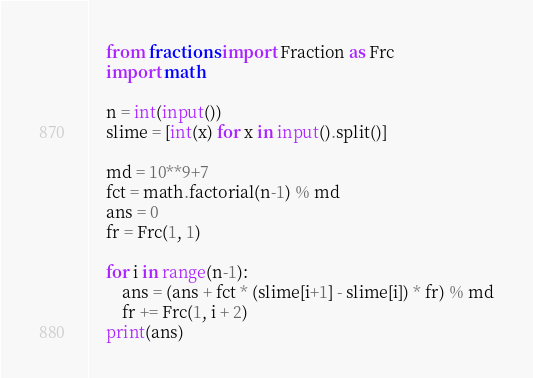<code> <loc_0><loc_0><loc_500><loc_500><_Python_>    from fractions import Fraction as Frc
    import math
     
    n = int(input())
    slime = [int(x) for x in input().split()]
     
    md = 10**9+7
    fct = math.factorial(n-1) % md
    ans = 0
    fr = Frc(1, 1)
     
    for i in range(n-1):
        ans = (ans + fct * (slime[i+1] - slime[i]) * fr) % md
        fr += Frc(1, i + 2)
    print(ans)</code> 